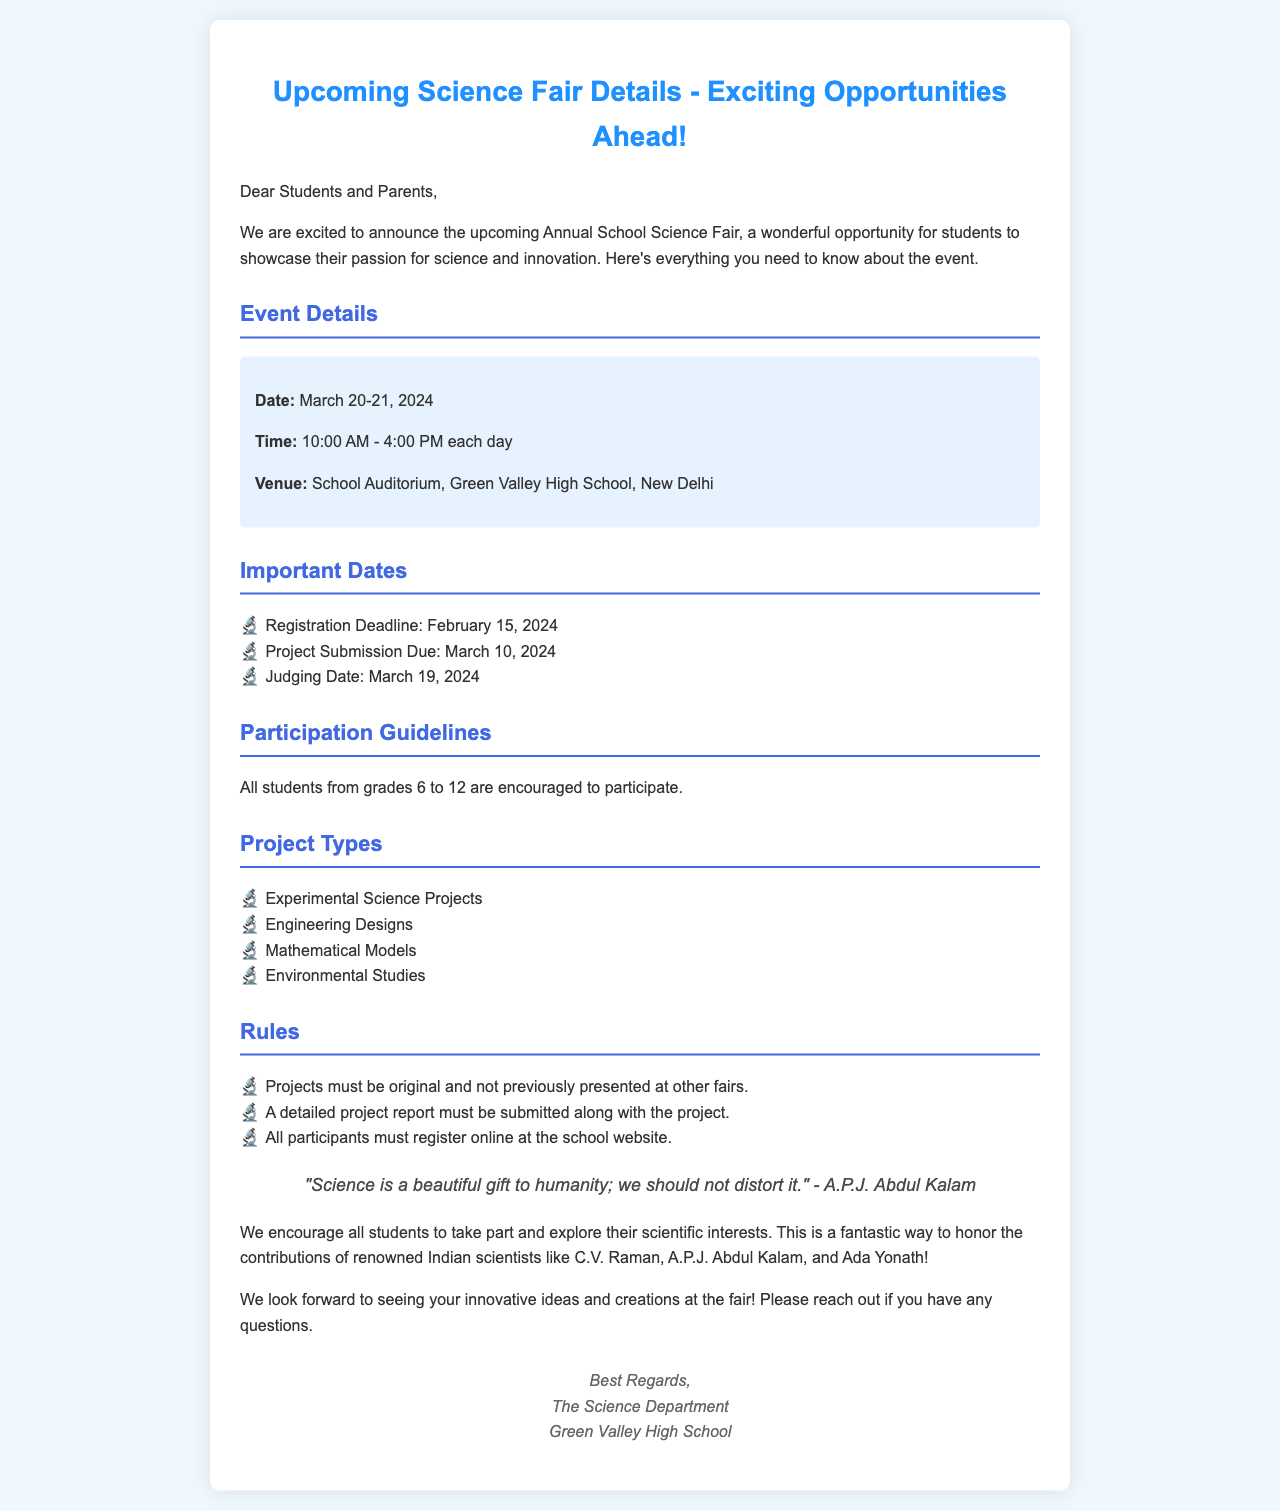What are the dates of the science fair? The document mentions that the science fair is on March 20-21, 2024.
Answer: March 20-21, 2024 What is the venue of the science fair? The venue is specified as the School Auditorium, Green Valley High School, New Delhi.
Answer: School Auditorium, Green Valley High School, New Delhi When is the registration deadline? The registration deadline is provided as February 15, 2024.
Answer: February 15, 2024 What types of projects are allowed at the fair? The document lists types of projects including Experimental Science Projects, Engineering Designs, Mathematical Models, and Environmental Studies.
Answer: Experimental Science Projects, Engineering Designs, Mathematical Models, Environmental Studies How many hours will the fair run each day? The document states that the fair will run from 10:00 AM to 4:00 PM each day, which is a total of 6 hours.
Answer: 6 hours Why must projects be original? The document notes that projects must not be previously presented at other fairs to ensure originality.
Answer: To ensure originality What grades are eligible to participate? It is noted that students from grades 6 to 12 are encouraged to participate in the fair.
Answer: Grades 6 to 12 What is required along with the project submission? A detailed project report must be submitted along with the project, as indicated in the rules section.
Answer: A detailed project report 